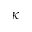<formula> <loc_0><loc_0><loc_500><loc_500>\kappa</formula> 